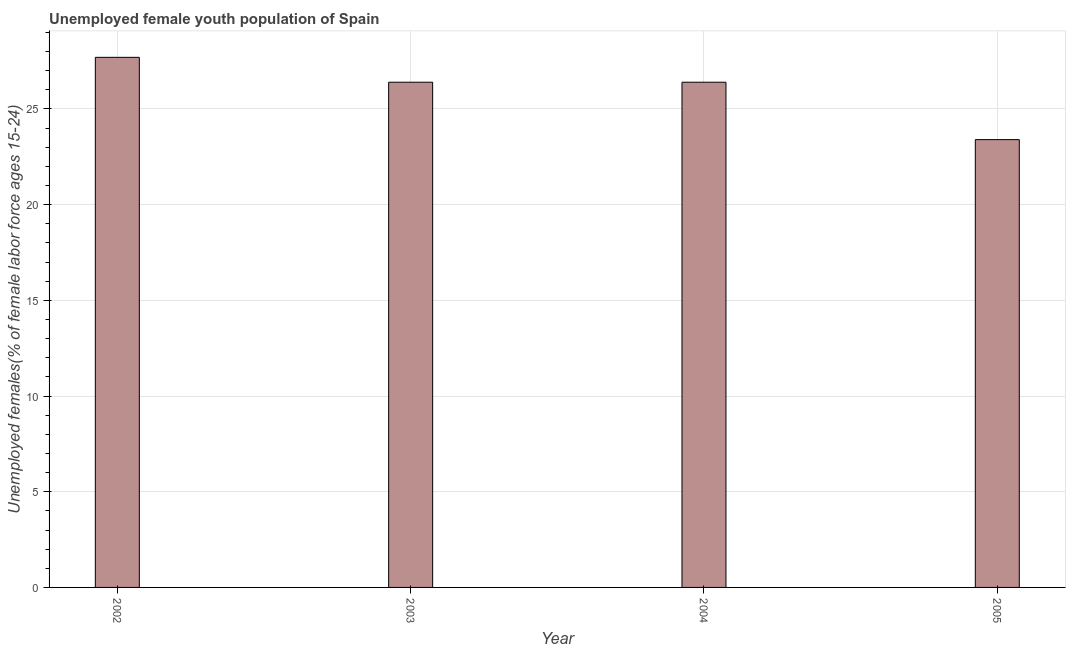Does the graph contain any zero values?
Your answer should be very brief. No. Does the graph contain grids?
Provide a short and direct response. Yes. What is the title of the graph?
Your response must be concise. Unemployed female youth population of Spain. What is the label or title of the Y-axis?
Provide a short and direct response. Unemployed females(% of female labor force ages 15-24). What is the unemployed female youth in 2002?
Provide a succinct answer. 27.7. Across all years, what is the maximum unemployed female youth?
Your response must be concise. 27.7. Across all years, what is the minimum unemployed female youth?
Give a very brief answer. 23.4. What is the sum of the unemployed female youth?
Provide a short and direct response. 103.9. What is the difference between the unemployed female youth in 2004 and 2005?
Ensure brevity in your answer.  3. What is the average unemployed female youth per year?
Provide a succinct answer. 25.98. What is the median unemployed female youth?
Keep it short and to the point. 26.4. Do a majority of the years between 2002 and 2005 (inclusive) have unemployed female youth greater than 14 %?
Give a very brief answer. Yes. What is the ratio of the unemployed female youth in 2002 to that in 2003?
Make the answer very short. 1.05. Is the unemployed female youth in 2002 less than that in 2005?
Offer a terse response. No. Is the sum of the unemployed female youth in 2003 and 2005 greater than the maximum unemployed female youth across all years?
Your answer should be very brief. Yes. Are all the bars in the graph horizontal?
Your answer should be very brief. No. How many years are there in the graph?
Keep it short and to the point. 4. What is the difference between two consecutive major ticks on the Y-axis?
Make the answer very short. 5. What is the Unemployed females(% of female labor force ages 15-24) of 2002?
Your answer should be compact. 27.7. What is the Unemployed females(% of female labor force ages 15-24) in 2003?
Offer a very short reply. 26.4. What is the Unemployed females(% of female labor force ages 15-24) in 2004?
Offer a terse response. 26.4. What is the Unemployed females(% of female labor force ages 15-24) of 2005?
Your response must be concise. 23.4. What is the difference between the Unemployed females(% of female labor force ages 15-24) in 2002 and 2004?
Your answer should be compact. 1.3. What is the difference between the Unemployed females(% of female labor force ages 15-24) in 2003 and 2005?
Offer a terse response. 3. What is the ratio of the Unemployed females(% of female labor force ages 15-24) in 2002 to that in 2003?
Offer a very short reply. 1.05. What is the ratio of the Unemployed females(% of female labor force ages 15-24) in 2002 to that in 2004?
Offer a terse response. 1.05. What is the ratio of the Unemployed females(% of female labor force ages 15-24) in 2002 to that in 2005?
Your response must be concise. 1.18. What is the ratio of the Unemployed females(% of female labor force ages 15-24) in 2003 to that in 2004?
Make the answer very short. 1. What is the ratio of the Unemployed females(% of female labor force ages 15-24) in 2003 to that in 2005?
Offer a very short reply. 1.13. What is the ratio of the Unemployed females(% of female labor force ages 15-24) in 2004 to that in 2005?
Ensure brevity in your answer.  1.13. 